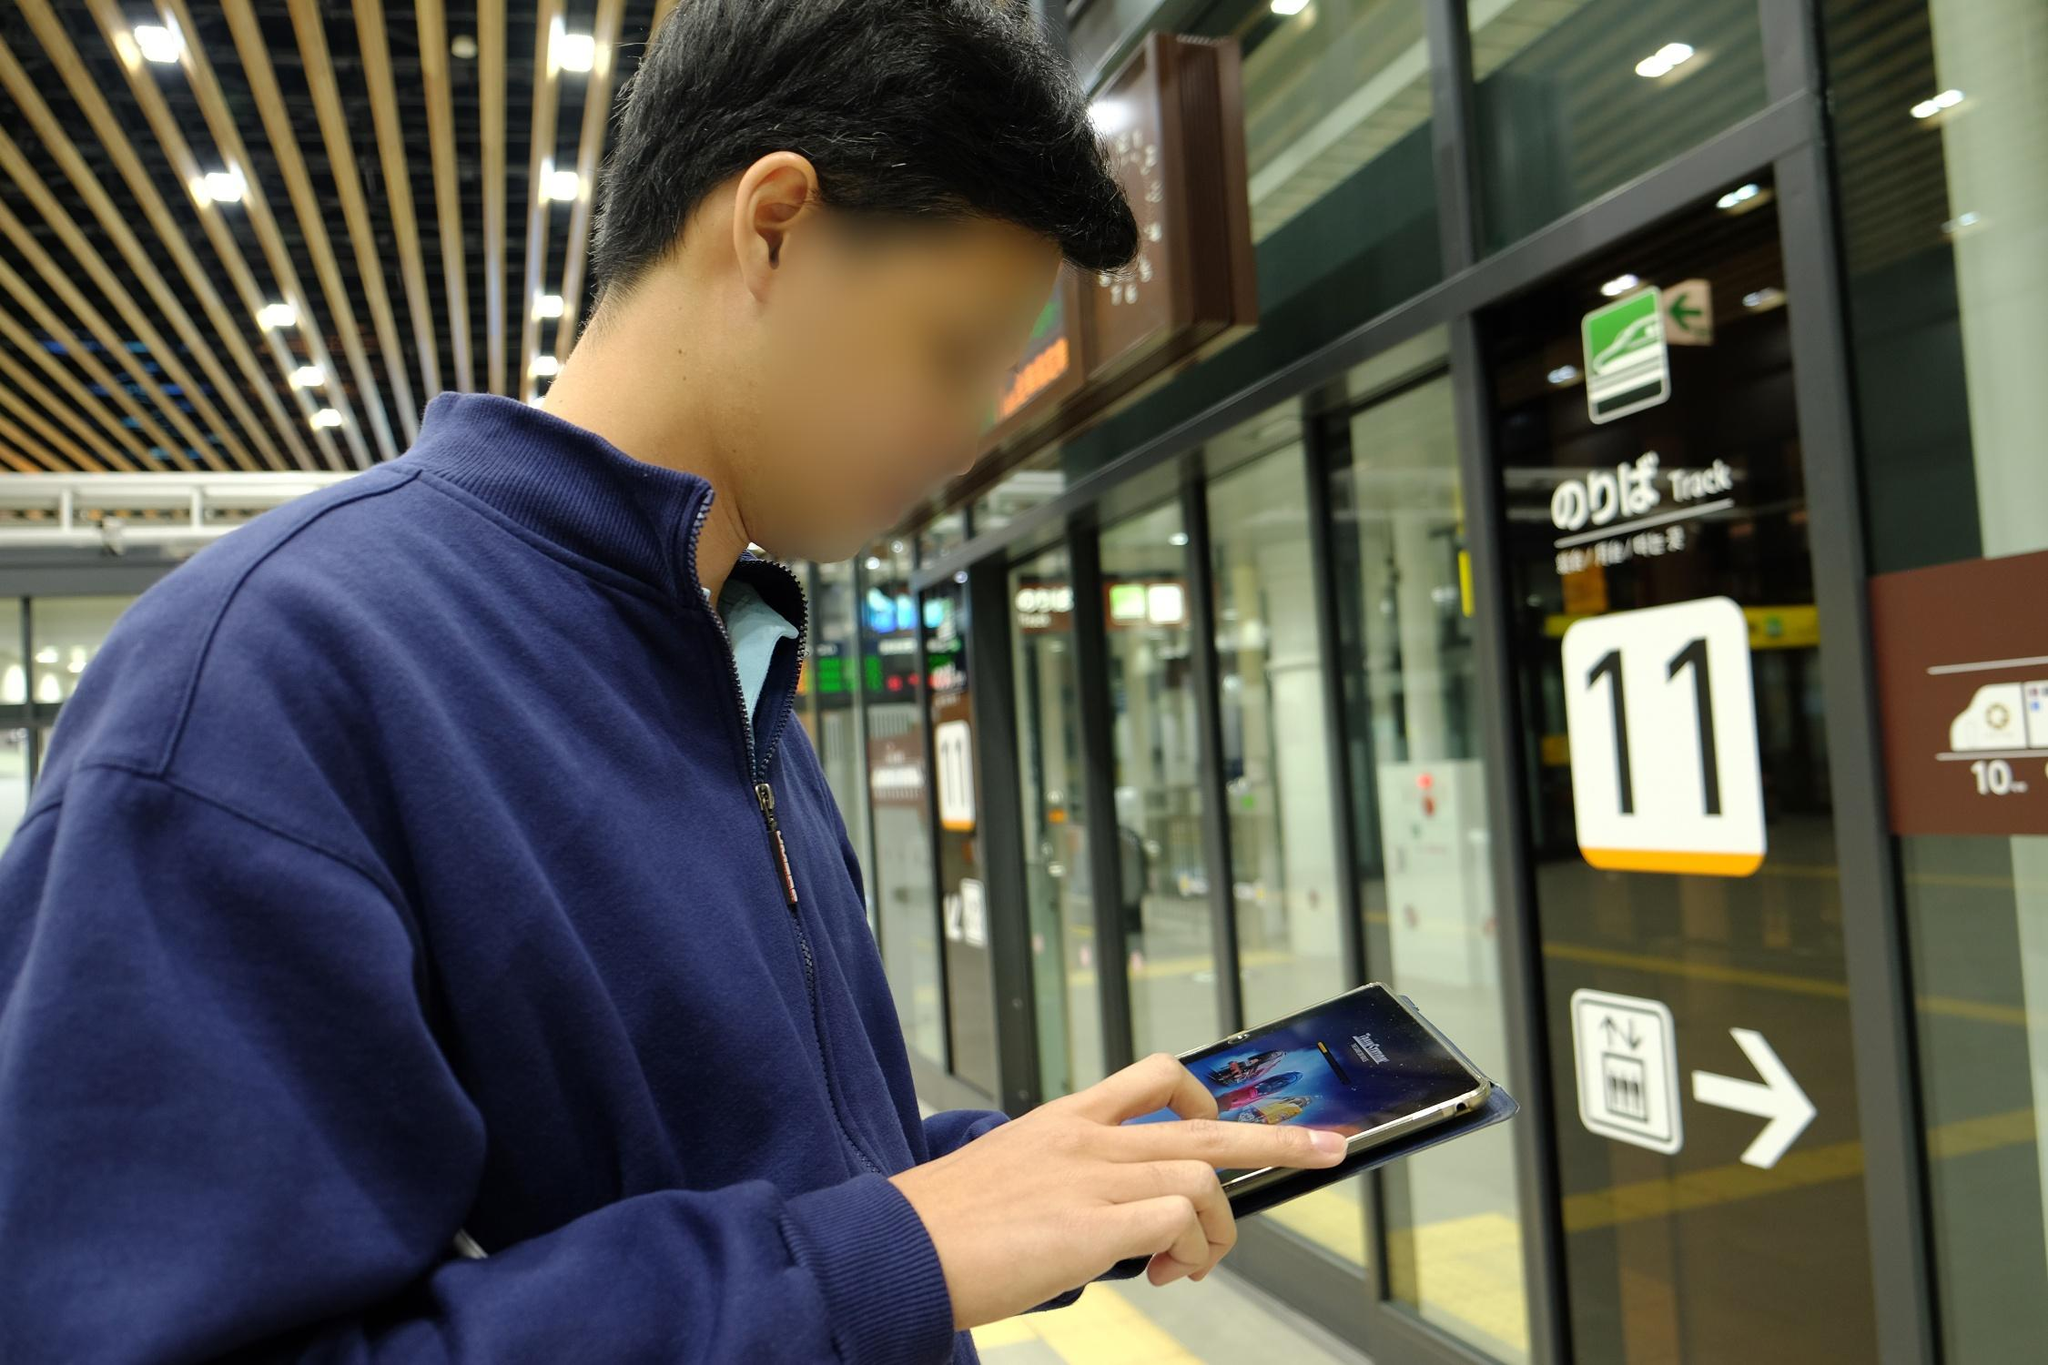Could you tell me a story inspired by this image involving a mysterious encounter? In the bustling train station, under the modern lights and amidst the sea of hurried travelers, a young man named Alex stood engrossed in his phone. He had been on an extended journey across the country, each stop filled with new experiences and sights. As he waited for his train at Track 11, he noticed an old woman who seemed out of place in the modern station. Her clothes were worn but neatly kept, and she clutched an ancient-looking book close to her chest. Curiosity piqued, Alex found his eyes constantly drawn to her.

Suddenly, the old woman approached him with a knowing smile. 'You're seeking something, aren’t you?' she asked cryptically. Before Alex could respond, she pressed the book into his hands and whispered, 'This will guide you.' Then, as if she vanished into thin air, she disappeared into the crowd.

Alex watched, stunned, as the letters on the cover of the book began to glow faintly. Inside, he found a map leading to hidden places and untold stories that seemed interwoven with his life. The train station, once just a transit point, had become the start of a grand adventure filled with ancient secrets and unexpected allies. 